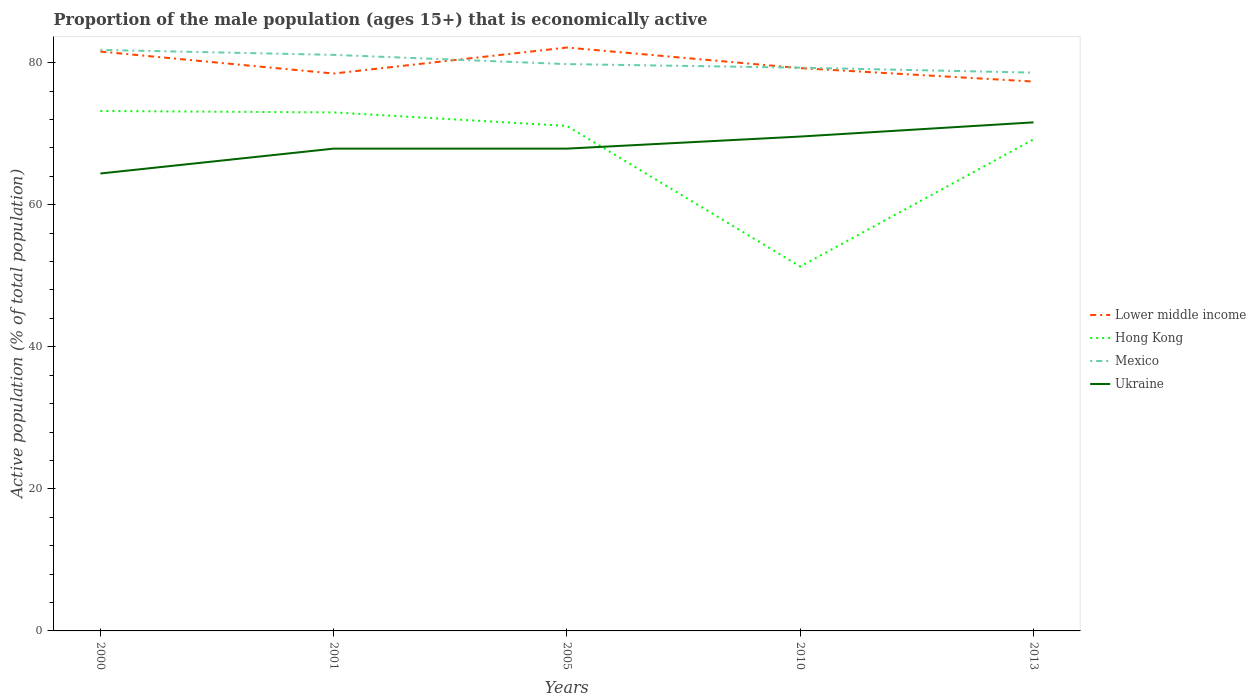How many different coloured lines are there?
Ensure brevity in your answer.  4. Is the number of lines equal to the number of legend labels?
Ensure brevity in your answer.  Yes. Across all years, what is the maximum proportion of the male population that is economically active in Hong Kong?
Your answer should be very brief. 51.3. In which year was the proportion of the male population that is economically active in Mexico maximum?
Give a very brief answer. 2013. What is the total proportion of the male population that is economically active in Lower middle income in the graph?
Your response must be concise. -0.76. What is the difference between the highest and the second highest proportion of the male population that is economically active in Hong Kong?
Keep it short and to the point. 21.9. How many lines are there?
Your response must be concise. 4. What is the difference between two consecutive major ticks on the Y-axis?
Give a very brief answer. 20. Are the values on the major ticks of Y-axis written in scientific E-notation?
Provide a short and direct response. No. Does the graph contain any zero values?
Offer a terse response. No. Does the graph contain grids?
Keep it short and to the point. No. How are the legend labels stacked?
Ensure brevity in your answer.  Vertical. What is the title of the graph?
Your answer should be very brief. Proportion of the male population (ages 15+) that is economically active. Does "Switzerland" appear as one of the legend labels in the graph?
Provide a succinct answer. No. What is the label or title of the X-axis?
Your response must be concise. Years. What is the label or title of the Y-axis?
Make the answer very short. Active population (% of total population). What is the Active population (% of total population) in Lower middle income in 2000?
Provide a succinct answer. 81.56. What is the Active population (% of total population) of Hong Kong in 2000?
Offer a very short reply. 73.2. What is the Active population (% of total population) in Mexico in 2000?
Keep it short and to the point. 81.8. What is the Active population (% of total population) in Ukraine in 2000?
Provide a short and direct response. 64.4. What is the Active population (% of total population) in Lower middle income in 2001?
Keep it short and to the point. 78.47. What is the Active population (% of total population) in Hong Kong in 2001?
Ensure brevity in your answer.  73. What is the Active population (% of total population) of Mexico in 2001?
Provide a succinct answer. 81.1. What is the Active population (% of total population) in Ukraine in 2001?
Offer a terse response. 67.9. What is the Active population (% of total population) of Lower middle income in 2005?
Your response must be concise. 82.13. What is the Active population (% of total population) in Hong Kong in 2005?
Your response must be concise. 71.1. What is the Active population (% of total population) of Mexico in 2005?
Your answer should be compact. 79.8. What is the Active population (% of total population) in Ukraine in 2005?
Give a very brief answer. 67.9. What is the Active population (% of total population) of Lower middle income in 2010?
Keep it short and to the point. 79.24. What is the Active population (% of total population) of Hong Kong in 2010?
Keep it short and to the point. 51.3. What is the Active population (% of total population) in Mexico in 2010?
Offer a very short reply. 79.3. What is the Active population (% of total population) in Ukraine in 2010?
Give a very brief answer. 69.6. What is the Active population (% of total population) of Lower middle income in 2013?
Keep it short and to the point. 77.34. What is the Active population (% of total population) of Hong Kong in 2013?
Give a very brief answer. 69.2. What is the Active population (% of total population) in Mexico in 2013?
Your answer should be compact. 78.6. What is the Active population (% of total population) in Ukraine in 2013?
Make the answer very short. 71.6. Across all years, what is the maximum Active population (% of total population) of Lower middle income?
Your response must be concise. 82.13. Across all years, what is the maximum Active population (% of total population) of Hong Kong?
Offer a very short reply. 73.2. Across all years, what is the maximum Active population (% of total population) of Mexico?
Your response must be concise. 81.8. Across all years, what is the maximum Active population (% of total population) in Ukraine?
Ensure brevity in your answer.  71.6. Across all years, what is the minimum Active population (% of total population) in Lower middle income?
Offer a very short reply. 77.34. Across all years, what is the minimum Active population (% of total population) of Hong Kong?
Your answer should be very brief. 51.3. Across all years, what is the minimum Active population (% of total population) of Mexico?
Make the answer very short. 78.6. Across all years, what is the minimum Active population (% of total population) of Ukraine?
Make the answer very short. 64.4. What is the total Active population (% of total population) of Lower middle income in the graph?
Your answer should be very brief. 398.75. What is the total Active population (% of total population) of Hong Kong in the graph?
Your answer should be compact. 337.8. What is the total Active population (% of total population) of Mexico in the graph?
Give a very brief answer. 400.6. What is the total Active population (% of total population) of Ukraine in the graph?
Offer a terse response. 341.4. What is the difference between the Active population (% of total population) in Lower middle income in 2000 and that in 2001?
Your answer should be very brief. 3.09. What is the difference between the Active population (% of total population) of Hong Kong in 2000 and that in 2001?
Your response must be concise. 0.2. What is the difference between the Active population (% of total population) of Mexico in 2000 and that in 2001?
Your answer should be compact. 0.7. What is the difference between the Active population (% of total population) in Ukraine in 2000 and that in 2001?
Your answer should be compact. -3.5. What is the difference between the Active population (% of total population) of Lower middle income in 2000 and that in 2005?
Provide a succinct answer. -0.57. What is the difference between the Active population (% of total population) in Hong Kong in 2000 and that in 2005?
Offer a terse response. 2.1. What is the difference between the Active population (% of total population) in Mexico in 2000 and that in 2005?
Your answer should be very brief. 2. What is the difference between the Active population (% of total population) in Ukraine in 2000 and that in 2005?
Provide a succinct answer. -3.5. What is the difference between the Active population (% of total population) in Lower middle income in 2000 and that in 2010?
Offer a very short reply. 2.33. What is the difference between the Active population (% of total population) in Hong Kong in 2000 and that in 2010?
Keep it short and to the point. 21.9. What is the difference between the Active population (% of total population) of Mexico in 2000 and that in 2010?
Make the answer very short. 2.5. What is the difference between the Active population (% of total population) in Lower middle income in 2000 and that in 2013?
Provide a succinct answer. 4.22. What is the difference between the Active population (% of total population) in Ukraine in 2000 and that in 2013?
Your answer should be very brief. -7.2. What is the difference between the Active population (% of total population) of Lower middle income in 2001 and that in 2005?
Offer a very short reply. -3.66. What is the difference between the Active population (% of total population) in Mexico in 2001 and that in 2005?
Ensure brevity in your answer.  1.3. What is the difference between the Active population (% of total population) in Ukraine in 2001 and that in 2005?
Give a very brief answer. 0. What is the difference between the Active population (% of total population) in Lower middle income in 2001 and that in 2010?
Your answer should be very brief. -0.76. What is the difference between the Active population (% of total population) of Hong Kong in 2001 and that in 2010?
Provide a short and direct response. 21.7. What is the difference between the Active population (% of total population) in Mexico in 2001 and that in 2010?
Your answer should be compact. 1.8. What is the difference between the Active population (% of total population) in Lower middle income in 2001 and that in 2013?
Ensure brevity in your answer.  1.13. What is the difference between the Active population (% of total population) in Mexico in 2001 and that in 2013?
Provide a succinct answer. 2.5. What is the difference between the Active population (% of total population) in Ukraine in 2001 and that in 2013?
Provide a short and direct response. -3.7. What is the difference between the Active population (% of total population) in Lower middle income in 2005 and that in 2010?
Offer a terse response. 2.9. What is the difference between the Active population (% of total population) of Hong Kong in 2005 and that in 2010?
Offer a terse response. 19.8. What is the difference between the Active population (% of total population) of Mexico in 2005 and that in 2010?
Your response must be concise. 0.5. What is the difference between the Active population (% of total population) in Lower middle income in 2005 and that in 2013?
Provide a short and direct response. 4.79. What is the difference between the Active population (% of total population) of Hong Kong in 2005 and that in 2013?
Provide a succinct answer. 1.9. What is the difference between the Active population (% of total population) in Lower middle income in 2010 and that in 2013?
Keep it short and to the point. 1.89. What is the difference between the Active population (% of total population) in Hong Kong in 2010 and that in 2013?
Make the answer very short. -17.9. What is the difference between the Active population (% of total population) in Lower middle income in 2000 and the Active population (% of total population) in Hong Kong in 2001?
Offer a very short reply. 8.56. What is the difference between the Active population (% of total population) in Lower middle income in 2000 and the Active population (% of total population) in Mexico in 2001?
Make the answer very short. 0.46. What is the difference between the Active population (% of total population) of Lower middle income in 2000 and the Active population (% of total population) of Ukraine in 2001?
Provide a short and direct response. 13.66. What is the difference between the Active population (% of total population) in Mexico in 2000 and the Active population (% of total population) in Ukraine in 2001?
Your response must be concise. 13.9. What is the difference between the Active population (% of total population) in Lower middle income in 2000 and the Active population (% of total population) in Hong Kong in 2005?
Give a very brief answer. 10.46. What is the difference between the Active population (% of total population) of Lower middle income in 2000 and the Active population (% of total population) of Mexico in 2005?
Provide a succinct answer. 1.76. What is the difference between the Active population (% of total population) in Lower middle income in 2000 and the Active population (% of total population) in Ukraine in 2005?
Your answer should be compact. 13.66. What is the difference between the Active population (% of total population) in Hong Kong in 2000 and the Active population (% of total population) in Ukraine in 2005?
Your response must be concise. 5.3. What is the difference between the Active population (% of total population) of Lower middle income in 2000 and the Active population (% of total population) of Hong Kong in 2010?
Make the answer very short. 30.26. What is the difference between the Active population (% of total population) in Lower middle income in 2000 and the Active population (% of total population) in Mexico in 2010?
Your response must be concise. 2.26. What is the difference between the Active population (% of total population) of Lower middle income in 2000 and the Active population (% of total population) of Ukraine in 2010?
Offer a terse response. 11.96. What is the difference between the Active population (% of total population) in Hong Kong in 2000 and the Active population (% of total population) in Mexico in 2010?
Give a very brief answer. -6.1. What is the difference between the Active population (% of total population) of Hong Kong in 2000 and the Active population (% of total population) of Ukraine in 2010?
Provide a short and direct response. 3.6. What is the difference between the Active population (% of total population) in Mexico in 2000 and the Active population (% of total population) in Ukraine in 2010?
Make the answer very short. 12.2. What is the difference between the Active population (% of total population) of Lower middle income in 2000 and the Active population (% of total population) of Hong Kong in 2013?
Make the answer very short. 12.36. What is the difference between the Active population (% of total population) in Lower middle income in 2000 and the Active population (% of total population) in Mexico in 2013?
Your answer should be very brief. 2.96. What is the difference between the Active population (% of total population) in Lower middle income in 2000 and the Active population (% of total population) in Ukraine in 2013?
Keep it short and to the point. 9.96. What is the difference between the Active population (% of total population) of Hong Kong in 2000 and the Active population (% of total population) of Mexico in 2013?
Your answer should be compact. -5.4. What is the difference between the Active population (% of total population) of Lower middle income in 2001 and the Active population (% of total population) of Hong Kong in 2005?
Your answer should be compact. 7.37. What is the difference between the Active population (% of total population) in Lower middle income in 2001 and the Active population (% of total population) in Mexico in 2005?
Offer a very short reply. -1.33. What is the difference between the Active population (% of total population) in Lower middle income in 2001 and the Active population (% of total population) in Ukraine in 2005?
Provide a short and direct response. 10.57. What is the difference between the Active population (% of total population) in Hong Kong in 2001 and the Active population (% of total population) in Ukraine in 2005?
Offer a terse response. 5.1. What is the difference between the Active population (% of total population) of Lower middle income in 2001 and the Active population (% of total population) of Hong Kong in 2010?
Ensure brevity in your answer.  27.17. What is the difference between the Active population (% of total population) of Lower middle income in 2001 and the Active population (% of total population) of Mexico in 2010?
Offer a terse response. -0.83. What is the difference between the Active population (% of total population) of Lower middle income in 2001 and the Active population (% of total population) of Ukraine in 2010?
Your response must be concise. 8.87. What is the difference between the Active population (% of total population) of Mexico in 2001 and the Active population (% of total population) of Ukraine in 2010?
Make the answer very short. 11.5. What is the difference between the Active population (% of total population) in Lower middle income in 2001 and the Active population (% of total population) in Hong Kong in 2013?
Provide a succinct answer. 9.27. What is the difference between the Active population (% of total population) of Lower middle income in 2001 and the Active population (% of total population) of Mexico in 2013?
Your response must be concise. -0.13. What is the difference between the Active population (% of total population) in Lower middle income in 2001 and the Active population (% of total population) in Ukraine in 2013?
Your answer should be very brief. 6.87. What is the difference between the Active population (% of total population) of Hong Kong in 2001 and the Active population (% of total population) of Ukraine in 2013?
Keep it short and to the point. 1.4. What is the difference between the Active population (% of total population) of Lower middle income in 2005 and the Active population (% of total population) of Hong Kong in 2010?
Give a very brief answer. 30.83. What is the difference between the Active population (% of total population) of Lower middle income in 2005 and the Active population (% of total population) of Mexico in 2010?
Your response must be concise. 2.83. What is the difference between the Active population (% of total population) of Lower middle income in 2005 and the Active population (% of total population) of Ukraine in 2010?
Provide a succinct answer. 12.53. What is the difference between the Active population (% of total population) in Mexico in 2005 and the Active population (% of total population) in Ukraine in 2010?
Offer a terse response. 10.2. What is the difference between the Active population (% of total population) in Lower middle income in 2005 and the Active population (% of total population) in Hong Kong in 2013?
Offer a very short reply. 12.93. What is the difference between the Active population (% of total population) in Lower middle income in 2005 and the Active population (% of total population) in Mexico in 2013?
Ensure brevity in your answer.  3.53. What is the difference between the Active population (% of total population) of Lower middle income in 2005 and the Active population (% of total population) of Ukraine in 2013?
Keep it short and to the point. 10.53. What is the difference between the Active population (% of total population) of Hong Kong in 2005 and the Active population (% of total population) of Mexico in 2013?
Your answer should be compact. -7.5. What is the difference between the Active population (% of total population) in Hong Kong in 2005 and the Active population (% of total population) in Ukraine in 2013?
Provide a short and direct response. -0.5. What is the difference between the Active population (% of total population) of Lower middle income in 2010 and the Active population (% of total population) of Hong Kong in 2013?
Offer a very short reply. 10.04. What is the difference between the Active population (% of total population) of Lower middle income in 2010 and the Active population (% of total population) of Mexico in 2013?
Keep it short and to the point. 0.64. What is the difference between the Active population (% of total population) in Lower middle income in 2010 and the Active population (% of total population) in Ukraine in 2013?
Your answer should be very brief. 7.63. What is the difference between the Active population (% of total population) of Hong Kong in 2010 and the Active population (% of total population) of Mexico in 2013?
Give a very brief answer. -27.3. What is the difference between the Active population (% of total population) in Hong Kong in 2010 and the Active population (% of total population) in Ukraine in 2013?
Keep it short and to the point. -20.3. What is the difference between the Active population (% of total population) in Mexico in 2010 and the Active population (% of total population) in Ukraine in 2013?
Give a very brief answer. 7.7. What is the average Active population (% of total population) in Lower middle income per year?
Your answer should be compact. 79.75. What is the average Active population (% of total population) of Hong Kong per year?
Offer a very short reply. 67.56. What is the average Active population (% of total population) in Mexico per year?
Give a very brief answer. 80.12. What is the average Active population (% of total population) in Ukraine per year?
Ensure brevity in your answer.  68.28. In the year 2000, what is the difference between the Active population (% of total population) of Lower middle income and Active population (% of total population) of Hong Kong?
Your response must be concise. 8.36. In the year 2000, what is the difference between the Active population (% of total population) in Lower middle income and Active population (% of total population) in Mexico?
Ensure brevity in your answer.  -0.24. In the year 2000, what is the difference between the Active population (% of total population) of Lower middle income and Active population (% of total population) of Ukraine?
Give a very brief answer. 17.16. In the year 2001, what is the difference between the Active population (% of total population) in Lower middle income and Active population (% of total population) in Hong Kong?
Offer a very short reply. 5.47. In the year 2001, what is the difference between the Active population (% of total population) in Lower middle income and Active population (% of total population) in Mexico?
Provide a short and direct response. -2.63. In the year 2001, what is the difference between the Active population (% of total population) of Lower middle income and Active population (% of total population) of Ukraine?
Your response must be concise. 10.57. In the year 2005, what is the difference between the Active population (% of total population) in Lower middle income and Active population (% of total population) in Hong Kong?
Offer a very short reply. 11.03. In the year 2005, what is the difference between the Active population (% of total population) in Lower middle income and Active population (% of total population) in Mexico?
Make the answer very short. 2.33. In the year 2005, what is the difference between the Active population (% of total population) of Lower middle income and Active population (% of total population) of Ukraine?
Provide a succinct answer. 14.23. In the year 2005, what is the difference between the Active population (% of total population) of Mexico and Active population (% of total population) of Ukraine?
Provide a succinct answer. 11.9. In the year 2010, what is the difference between the Active population (% of total population) of Lower middle income and Active population (% of total population) of Hong Kong?
Keep it short and to the point. 27.93. In the year 2010, what is the difference between the Active population (% of total population) of Lower middle income and Active population (% of total population) of Mexico?
Your answer should be compact. -0.07. In the year 2010, what is the difference between the Active population (% of total population) of Lower middle income and Active population (% of total population) of Ukraine?
Provide a succinct answer. 9.63. In the year 2010, what is the difference between the Active population (% of total population) of Hong Kong and Active population (% of total population) of Mexico?
Give a very brief answer. -28. In the year 2010, what is the difference between the Active population (% of total population) in Hong Kong and Active population (% of total population) in Ukraine?
Offer a very short reply. -18.3. In the year 2013, what is the difference between the Active population (% of total population) in Lower middle income and Active population (% of total population) in Hong Kong?
Make the answer very short. 8.14. In the year 2013, what is the difference between the Active population (% of total population) in Lower middle income and Active population (% of total population) in Mexico?
Keep it short and to the point. -1.26. In the year 2013, what is the difference between the Active population (% of total population) of Lower middle income and Active population (% of total population) of Ukraine?
Offer a very short reply. 5.74. In the year 2013, what is the difference between the Active population (% of total population) of Mexico and Active population (% of total population) of Ukraine?
Your answer should be compact. 7. What is the ratio of the Active population (% of total population) of Lower middle income in 2000 to that in 2001?
Ensure brevity in your answer.  1.04. What is the ratio of the Active population (% of total population) of Mexico in 2000 to that in 2001?
Offer a terse response. 1.01. What is the ratio of the Active population (% of total population) in Ukraine in 2000 to that in 2001?
Offer a terse response. 0.95. What is the ratio of the Active population (% of total population) of Lower middle income in 2000 to that in 2005?
Offer a terse response. 0.99. What is the ratio of the Active population (% of total population) of Hong Kong in 2000 to that in 2005?
Provide a short and direct response. 1.03. What is the ratio of the Active population (% of total population) in Mexico in 2000 to that in 2005?
Offer a terse response. 1.03. What is the ratio of the Active population (% of total population) in Ukraine in 2000 to that in 2005?
Provide a succinct answer. 0.95. What is the ratio of the Active population (% of total population) of Lower middle income in 2000 to that in 2010?
Make the answer very short. 1.03. What is the ratio of the Active population (% of total population) in Hong Kong in 2000 to that in 2010?
Your answer should be very brief. 1.43. What is the ratio of the Active population (% of total population) in Mexico in 2000 to that in 2010?
Keep it short and to the point. 1.03. What is the ratio of the Active population (% of total population) of Ukraine in 2000 to that in 2010?
Ensure brevity in your answer.  0.93. What is the ratio of the Active population (% of total population) in Lower middle income in 2000 to that in 2013?
Provide a short and direct response. 1.05. What is the ratio of the Active population (% of total population) in Hong Kong in 2000 to that in 2013?
Provide a succinct answer. 1.06. What is the ratio of the Active population (% of total population) of Mexico in 2000 to that in 2013?
Keep it short and to the point. 1.04. What is the ratio of the Active population (% of total population) in Ukraine in 2000 to that in 2013?
Give a very brief answer. 0.9. What is the ratio of the Active population (% of total population) in Lower middle income in 2001 to that in 2005?
Your response must be concise. 0.96. What is the ratio of the Active population (% of total population) in Hong Kong in 2001 to that in 2005?
Your response must be concise. 1.03. What is the ratio of the Active population (% of total population) in Mexico in 2001 to that in 2005?
Your answer should be compact. 1.02. What is the ratio of the Active population (% of total population) in Ukraine in 2001 to that in 2005?
Offer a terse response. 1. What is the ratio of the Active population (% of total population) in Hong Kong in 2001 to that in 2010?
Ensure brevity in your answer.  1.42. What is the ratio of the Active population (% of total population) in Mexico in 2001 to that in 2010?
Offer a very short reply. 1.02. What is the ratio of the Active population (% of total population) of Ukraine in 2001 to that in 2010?
Give a very brief answer. 0.98. What is the ratio of the Active population (% of total population) in Lower middle income in 2001 to that in 2013?
Offer a terse response. 1.01. What is the ratio of the Active population (% of total population) of Hong Kong in 2001 to that in 2013?
Offer a very short reply. 1.05. What is the ratio of the Active population (% of total population) in Mexico in 2001 to that in 2013?
Make the answer very short. 1.03. What is the ratio of the Active population (% of total population) in Ukraine in 2001 to that in 2013?
Offer a terse response. 0.95. What is the ratio of the Active population (% of total population) of Lower middle income in 2005 to that in 2010?
Your response must be concise. 1.04. What is the ratio of the Active population (% of total population) in Hong Kong in 2005 to that in 2010?
Your answer should be very brief. 1.39. What is the ratio of the Active population (% of total population) in Ukraine in 2005 to that in 2010?
Your answer should be compact. 0.98. What is the ratio of the Active population (% of total population) in Lower middle income in 2005 to that in 2013?
Provide a short and direct response. 1.06. What is the ratio of the Active population (% of total population) of Hong Kong in 2005 to that in 2013?
Your response must be concise. 1.03. What is the ratio of the Active population (% of total population) in Mexico in 2005 to that in 2013?
Keep it short and to the point. 1.02. What is the ratio of the Active population (% of total population) in Ukraine in 2005 to that in 2013?
Offer a very short reply. 0.95. What is the ratio of the Active population (% of total population) in Lower middle income in 2010 to that in 2013?
Your answer should be very brief. 1.02. What is the ratio of the Active population (% of total population) in Hong Kong in 2010 to that in 2013?
Keep it short and to the point. 0.74. What is the ratio of the Active population (% of total population) of Mexico in 2010 to that in 2013?
Offer a terse response. 1.01. What is the ratio of the Active population (% of total population) of Ukraine in 2010 to that in 2013?
Offer a terse response. 0.97. What is the difference between the highest and the second highest Active population (% of total population) of Lower middle income?
Give a very brief answer. 0.57. What is the difference between the highest and the second highest Active population (% of total population) of Hong Kong?
Offer a very short reply. 0.2. What is the difference between the highest and the second highest Active population (% of total population) in Ukraine?
Your response must be concise. 2. What is the difference between the highest and the lowest Active population (% of total population) in Lower middle income?
Offer a terse response. 4.79. What is the difference between the highest and the lowest Active population (% of total population) in Hong Kong?
Give a very brief answer. 21.9. 